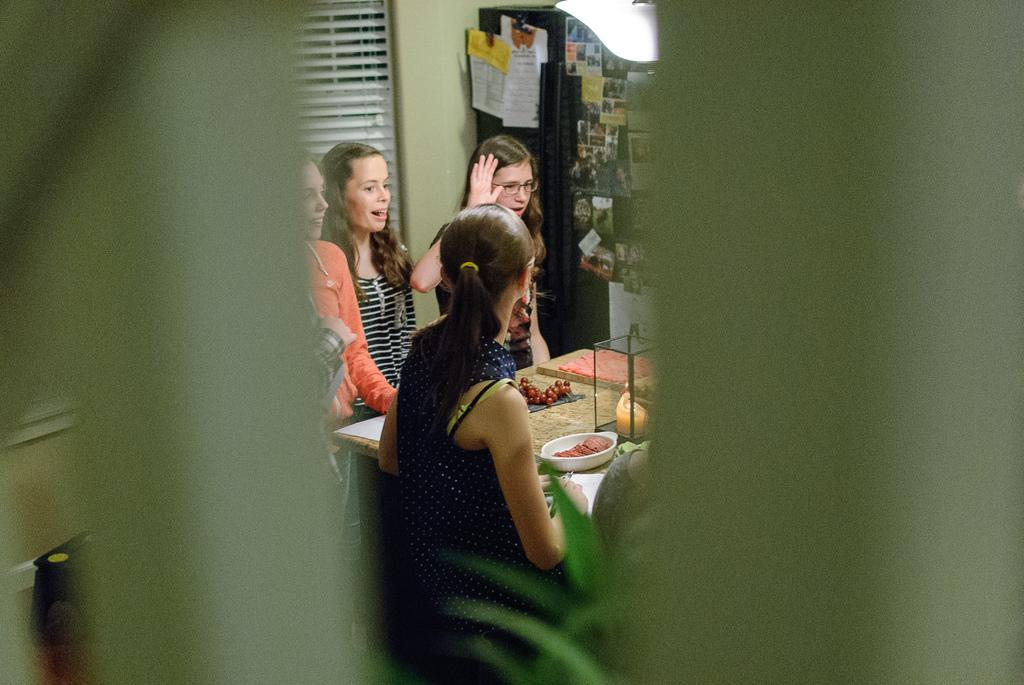Who or what can be seen in the image? There are people in the image. What is the background of the image? There is a wall in the image. Are there any decorations or items on the wall? There are photos in the image. What furniture is present in the image? There is a table in the image. What is on the table? There is a bowl on the table and grapes on the table. What type of grass is growing on the face of the person in the image? There is no grass or face visible in the image; it features people, a wall, photos, a table, a bowl, and grapes. 